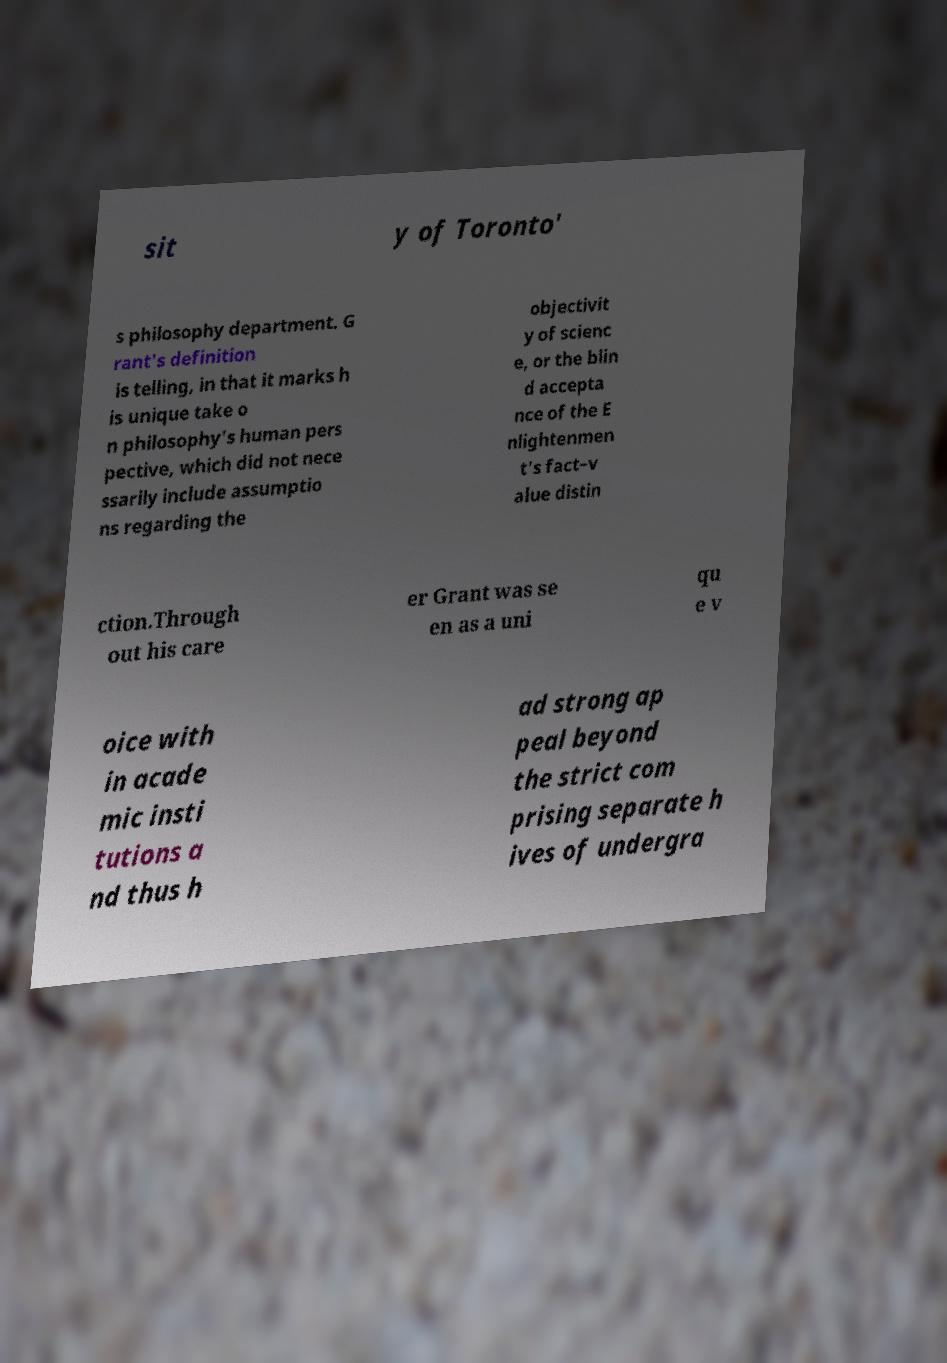There's text embedded in this image that I need extracted. Can you transcribe it verbatim? sit y of Toronto' s philosophy department. G rant's definition is telling, in that it marks h is unique take o n philosophy's human pers pective, which did not nece ssarily include assumptio ns regarding the objectivit y of scienc e, or the blin d accepta nce of the E nlightenmen t's fact–v alue distin ction.Through out his care er Grant was se en as a uni qu e v oice with in acade mic insti tutions a nd thus h ad strong ap peal beyond the strict com prising separate h ives of undergra 